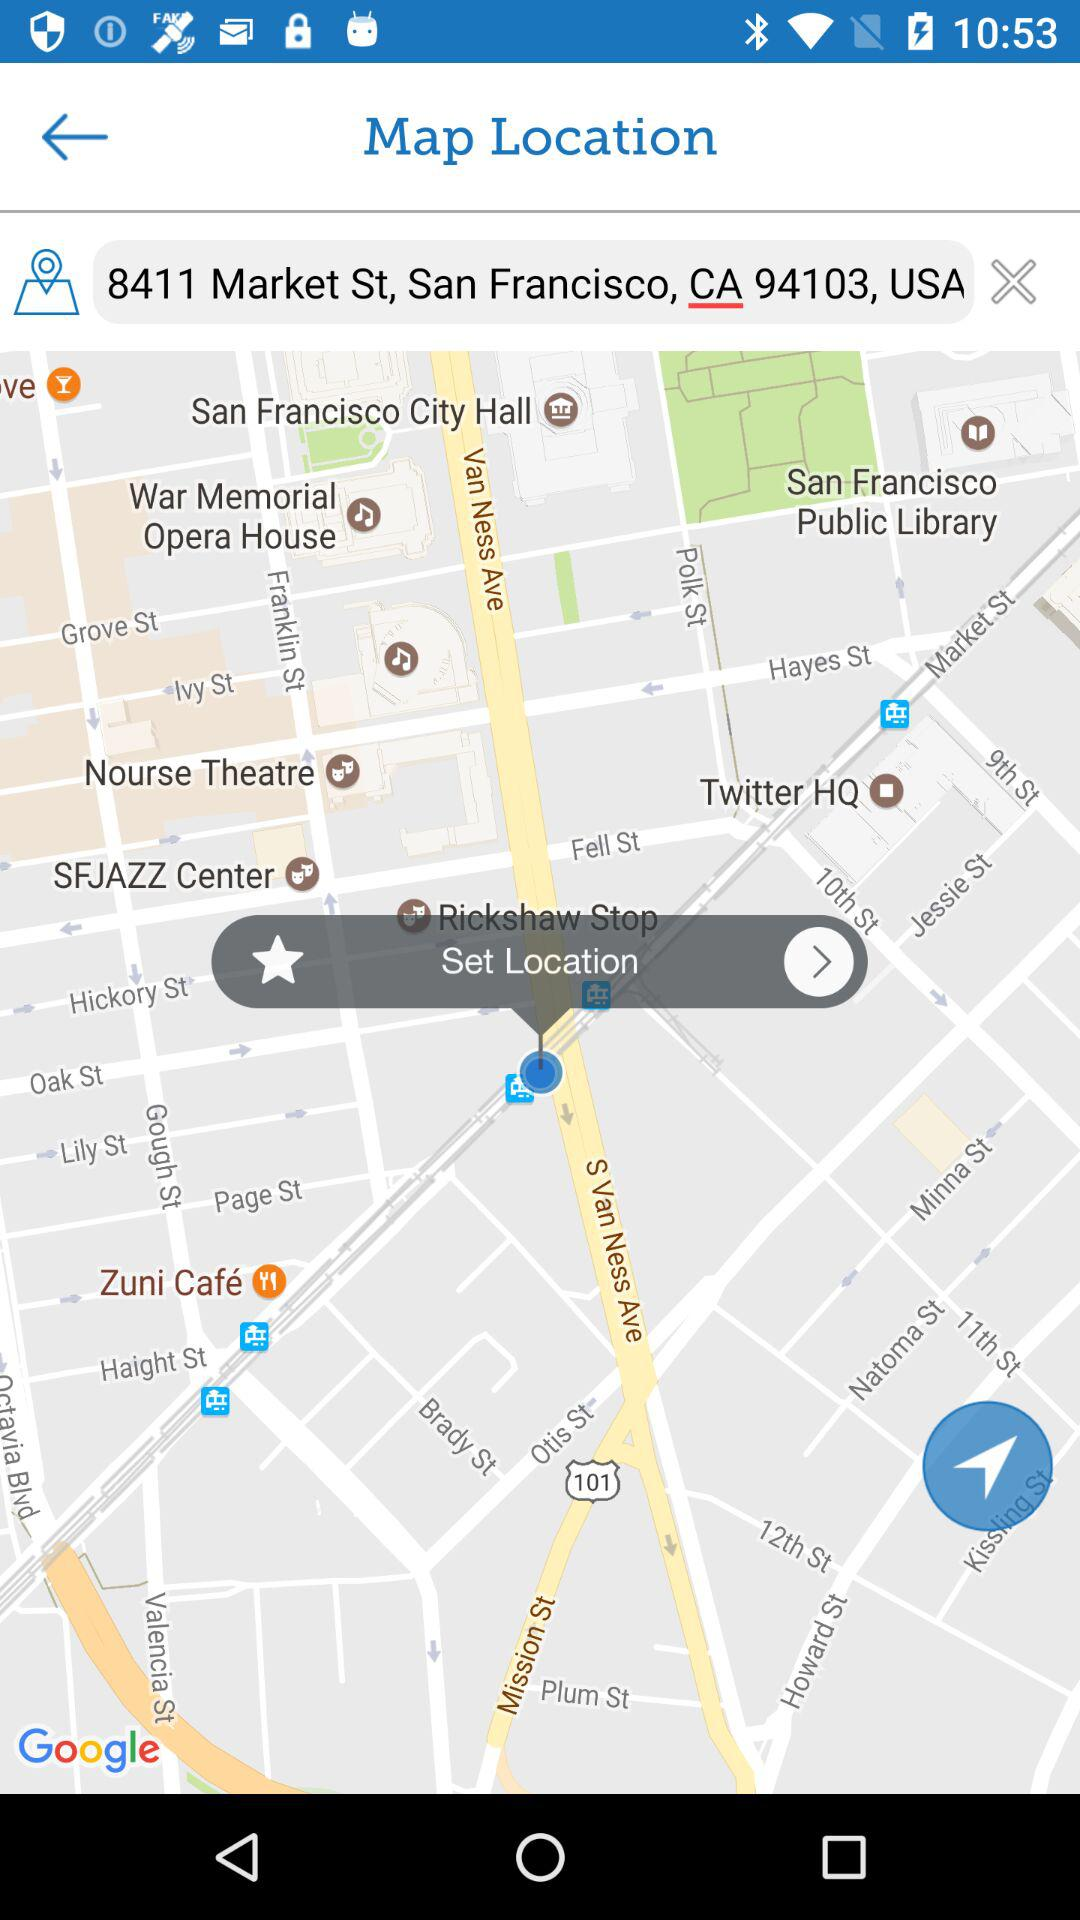What is the set location on the map? The set location on the map is 8411 Market St, San Francisco, CA 94103, USA. 